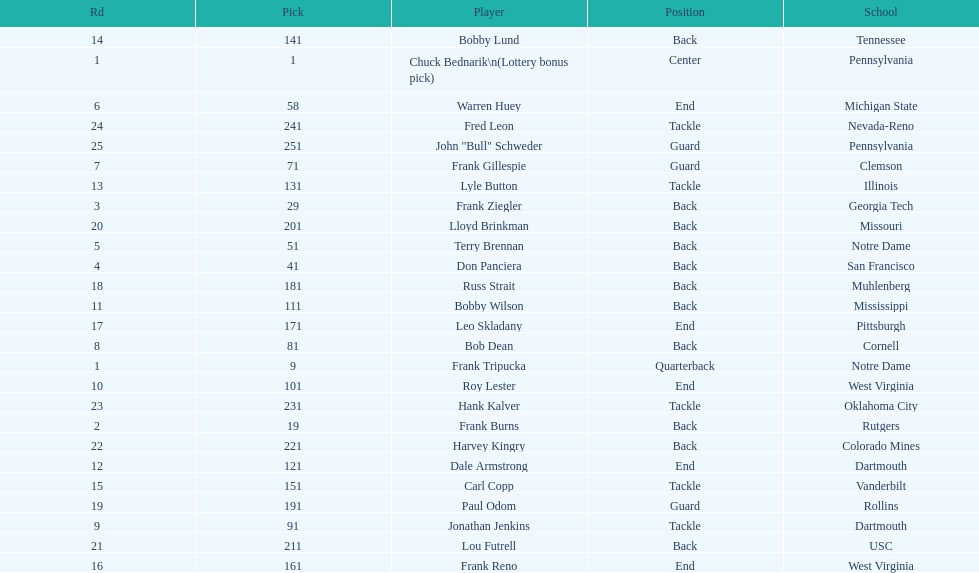Was chuck bednarik or frank tripucka the first draft pick? Chuck Bednarik. 